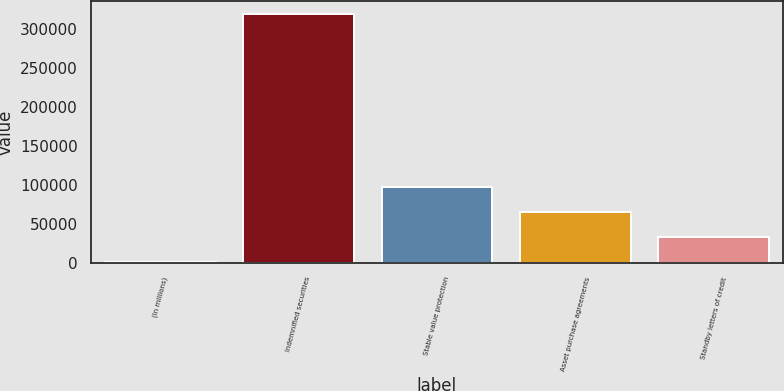Convert chart. <chart><loc_0><loc_0><loc_500><loc_500><bar_chart><fcel>(In millions)<fcel>Indemnified securities<fcel>Stable value protection<fcel>Asset purchase agreements<fcel>Standby letters of credit<nl><fcel>2013<fcel>320078<fcel>97432.5<fcel>65626<fcel>33819.5<nl></chart> 